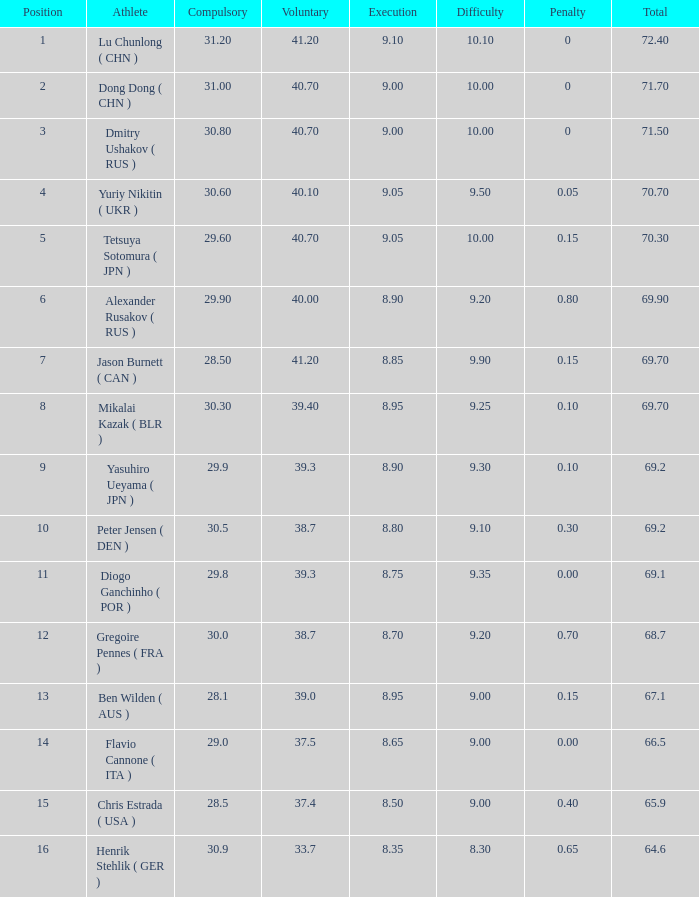Would you mind parsing the complete table? {'header': ['Position', 'Athlete', 'Compulsory', 'Voluntary', 'Execution', 'Difficulty', 'Penalty', 'Total'], 'rows': [['1', 'Lu Chunlong ( CHN )', '31.20', '41.20', '9.10', '10.10', '0', '72.40'], ['2', 'Dong Dong ( CHN )', '31.00', '40.70', '9.00', '10.00', '0', '71.70'], ['3', 'Dmitry Ushakov ( RUS )', '30.80', '40.70', '9.00', '10.00', '0', '71.50'], ['4', 'Yuriy Nikitin ( UKR )', '30.60', '40.10', '9.05', '9.50', '0.05', '70.70'], ['5', 'Tetsuya Sotomura ( JPN )', '29.60', '40.70', '9.05', '10.00', '0.15', '70.30'], ['6', 'Alexander Rusakov ( RUS )', '29.90', '40.00', '8.90', '9.20', '0.80', '69.90'], ['7', 'Jason Burnett ( CAN )', '28.50', '41.20', '8.85', '9.90', '0.15', '69.70'], ['8', 'Mikalai Kazak ( BLR )', '30.30', '39.40', '8.95', '9.25', '0.10', '69.70'], ['9', 'Yasuhiro Ueyama ( JPN )', '29.9', '39.3', '8.90', '9.30', '0.10', '69.2'], ['10', 'Peter Jensen ( DEN )', '30.5', '38.7', '8.80', '9.10', '0.30', '69.2'], ['11', 'Diogo Ganchinho ( POR )', '29.8', '39.3', '8.75', '9.35', '0.00', '69.1'], ['12', 'Gregoire Pennes ( FRA )', '30.0', '38.7', '8.70', '9.20', '0.70', '68.7'], ['13', 'Ben Wilden ( AUS )', '28.1', '39.0', '8.95', '9.00', '0.15', '67.1'], ['14', 'Flavio Cannone ( ITA )', '29.0', '37.5', '8.65', '9.00', '0.00', '66.5'], ['15', 'Chris Estrada ( USA )', '28.5', '37.4', '8.50', '9.00', '0.40', '65.9'], ['16', 'Henrik Stehlik ( GER )', '30.9', '33.7', '8.35', '8.30', '0.65', '64.6']]} What's the total of the position of 1? None. 